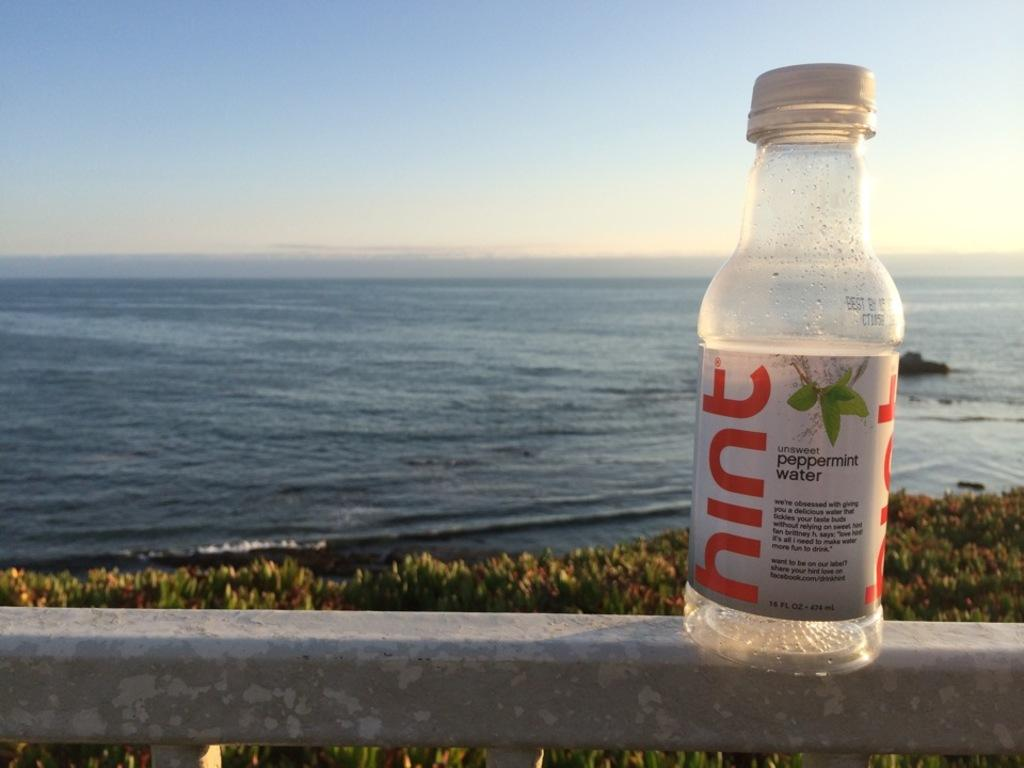What is on the wall in the image? There is a bottle with a label on the wall. What can be seen in the distance in the image? There is a sea visible in the background. What is in front of the wall in the image? There are plants in front of the wall. What color is the sky in the image? The sky is blue and visible at the top of the image. How many cars are parked near the plants in the image? There are no cars present in the image. What type of sail can be seen on the sea in the image? There is no sail visible in the image, as it only shows a sea in the background. 